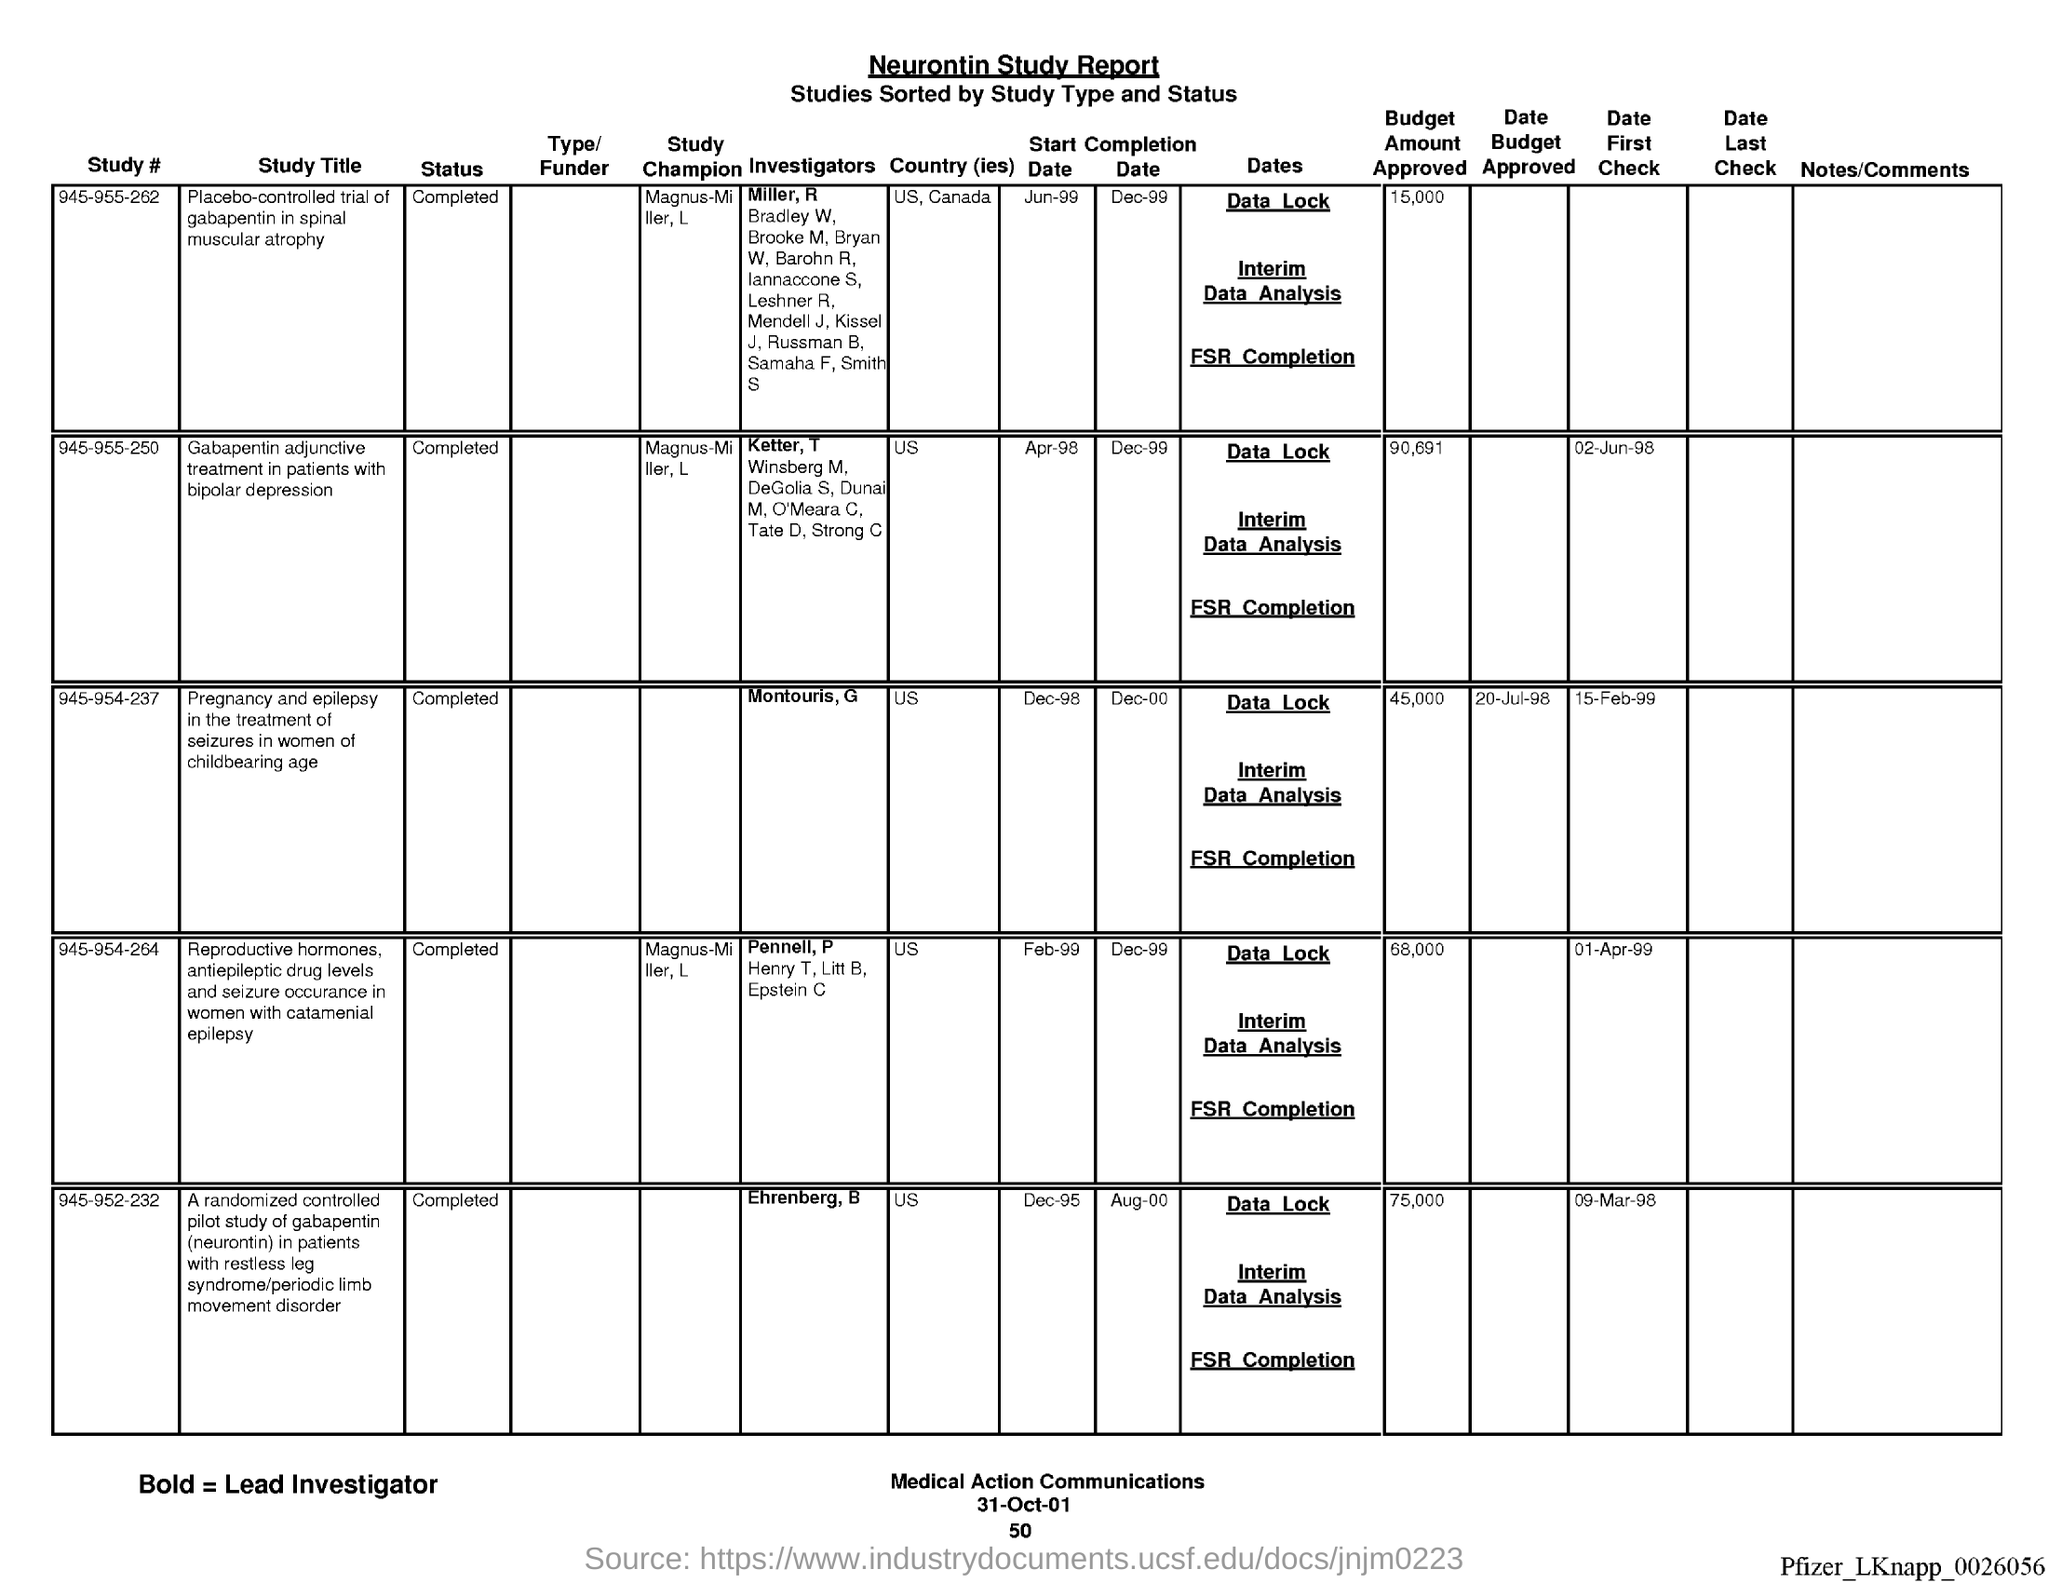List a handful of essential elements in this visual. The country of study is located between the numbers 945-955-262. The country is either the United States or Canada. The country of study is number 945-964-264, and it is located in the United States. What is the country of study # 945-952-232? It is unknown. The study with the identifier #945-955-250 has been completed. The study with number # 945-964-264 has been completed. 